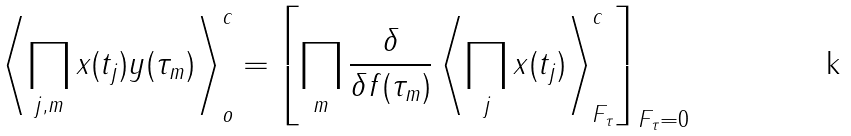Convert formula to latex. <formula><loc_0><loc_0><loc_500><loc_500>\left \langle \prod _ { j , m } x ( t _ { j } ) y ( \tau _ { m } ) \right \rangle _ { o } ^ { c } = \left [ \prod _ { m } \frac { \delta } { \delta f ( \tau _ { m } ) } \left \langle \prod _ { j } x ( t _ { j } ) \right \rangle _ { F _ { \tau } } ^ { c } \right ] _ { F _ { \tau } = 0 }</formula> 